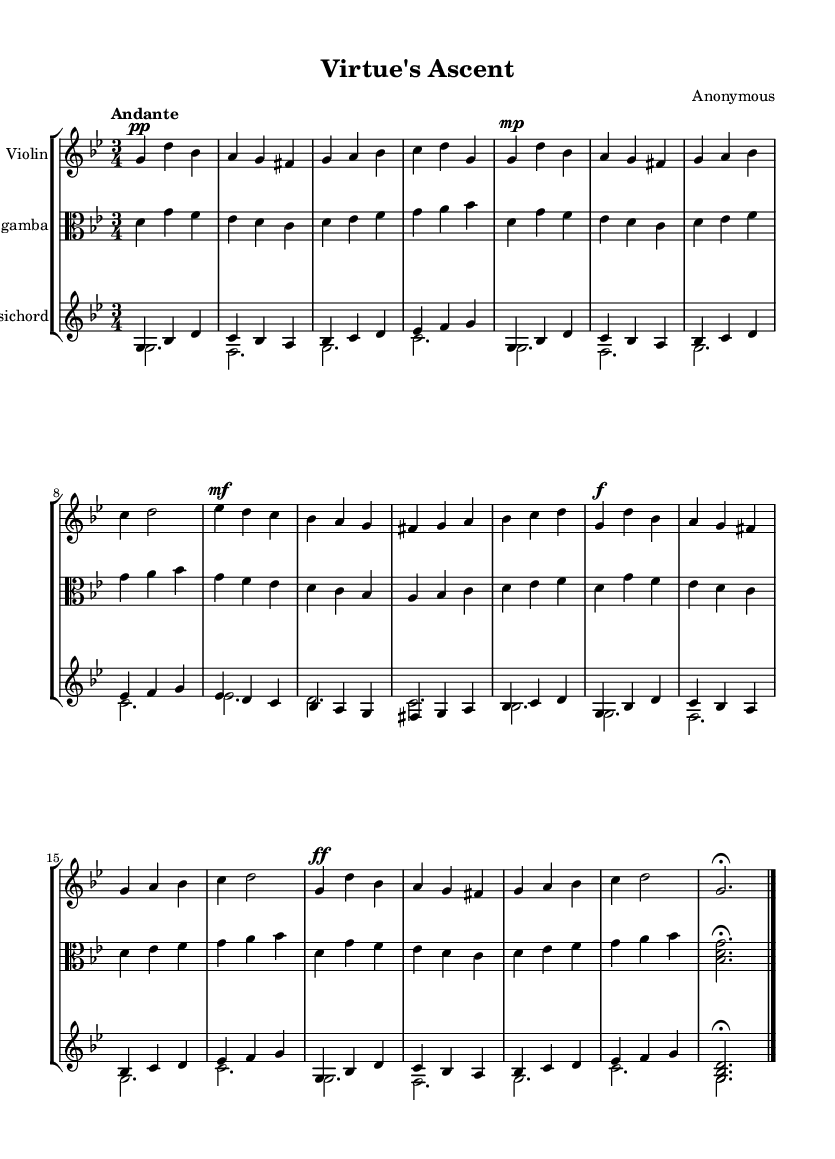What is the key signature of this music? The key signature is G minor, which includes two flats (B♭ and E♭). We identify this by looking at the key signature at the beginning of the staff, which indicates the notes affected by flats or sharps.
Answer: G minor What is the time signature of this music? The time signature is 3/4, meaning there are three beats per measure and the quarter note gets one beat. This is visible at the start of the score.
Answer: 3/4 What is the tempo marking for this piece? The tempo marking is "Andante," which suggests a moderately slow pace. This is indicated at the beginning of the score right above the musical staff.
Answer: Andante How many main themes are present in the music? There are two main themes present. Theme A represents virtue and Theme B represents struggle, differentiated in the score during the sections.
Answer: Two What is the dynamic marking for Theme A? The dynamic marking for Theme A is mezzo piano (mp), indicating a moderate softness. We can see this marking at the start of the Theme A section in the violin part.
Answer: Mezzo piano What type of ensemble performs this piece? The ensemble is a Baroque chamber music group, consisting of a violin, viola da gamba, and harpsichord. The score indicates three different instruments, typical for chamber music of the Baroque period.
Answer: Baroque chamber music In which part does the theme of redemption occur? The theme of redemption occurs in Theme A prime (A') section of the music. This section of the score is marked following the development section, indicating a return to a variation of Theme A.
Answer: Theme A prime 